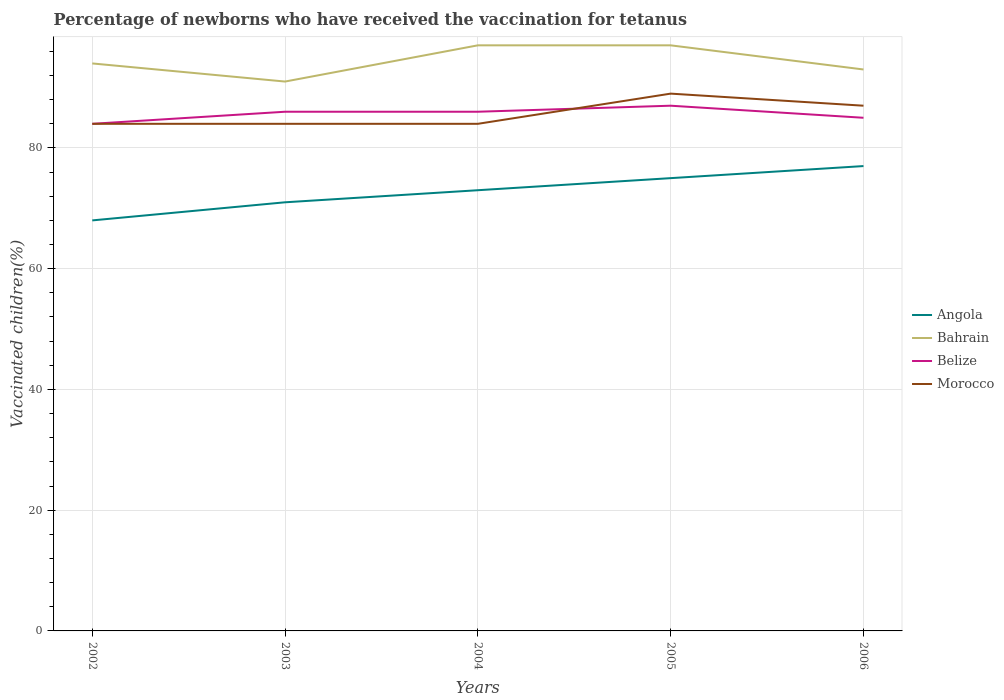How many different coloured lines are there?
Ensure brevity in your answer.  4. Does the line corresponding to Angola intersect with the line corresponding to Belize?
Ensure brevity in your answer.  No. In which year was the percentage of vaccinated children in Belize maximum?
Your answer should be very brief. 2002. What is the difference between the highest and the lowest percentage of vaccinated children in Belize?
Keep it short and to the point. 3. Is the percentage of vaccinated children in Belize strictly greater than the percentage of vaccinated children in Angola over the years?
Give a very brief answer. No. Are the values on the major ticks of Y-axis written in scientific E-notation?
Make the answer very short. No. Does the graph contain any zero values?
Offer a terse response. No. Where does the legend appear in the graph?
Keep it short and to the point. Center right. How many legend labels are there?
Offer a very short reply. 4. How are the legend labels stacked?
Your response must be concise. Vertical. What is the title of the graph?
Make the answer very short. Percentage of newborns who have received the vaccination for tetanus. What is the label or title of the X-axis?
Give a very brief answer. Years. What is the label or title of the Y-axis?
Provide a succinct answer. Vaccinated children(%). What is the Vaccinated children(%) in Bahrain in 2002?
Provide a succinct answer. 94. What is the Vaccinated children(%) in Belize in 2002?
Your answer should be compact. 84. What is the Vaccinated children(%) of Morocco in 2002?
Make the answer very short. 84. What is the Vaccinated children(%) in Bahrain in 2003?
Provide a short and direct response. 91. What is the Vaccinated children(%) of Belize in 2003?
Provide a short and direct response. 86. What is the Vaccinated children(%) of Bahrain in 2004?
Offer a terse response. 97. What is the Vaccinated children(%) of Morocco in 2004?
Provide a succinct answer. 84. What is the Vaccinated children(%) of Bahrain in 2005?
Offer a very short reply. 97. What is the Vaccinated children(%) of Morocco in 2005?
Offer a terse response. 89. What is the Vaccinated children(%) in Bahrain in 2006?
Your response must be concise. 93. What is the Vaccinated children(%) in Belize in 2006?
Give a very brief answer. 85. What is the Vaccinated children(%) in Morocco in 2006?
Your answer should be very brief. 87. Across all years, what is the maximum Vaccinated children(%) of Bahrain?
Give a very brief answer. 97. Across all years, what is the maximum Vaccinated children(%) of Belize?
Offer a terse response. 87. Across all years, what is the maximum Vaccinated children(%) in Morocco?
Your response must be concise. 89. Across all years, what is the minimum Vaccinated children(%) in Bahrain?
Ensure brevity in your answer.  91. What is the total Vaccinated children(%) of Angola in the graph?
Provide a succinct answer. 364. What is the total Vaccinated children(%) of Bahrain in the graph?
Ensure brevity in your answer.  472. What is the total Vaccinated children(%) of Belize in the graph?
Your response must be concise. 428. What is the total Vaccinated children(%) of Morocco in the graph?
Your response must be concise. 428. What is the difference between the Vaccinated children(%) of Angola in 2002 and that in 2003?
Your answer should be compact. -3. What is the difference between the Vaccinated children(%) in Angola in 2002 and that in 2004?
Your answer should be very brief. -5. What is the difference between the Vaccinated children(%) in Angola in 2002 and that in 2006?
Your answer should be compact. -9. What is the difference between the Vaccinated children(%) in Morocco in 2002 and that in 2006?
Your response must be concise. -3. What is the difference between the Vaccinated children(%) in Morocco in 2003 and that in 2004?
Ensure brevity in your answer.  0. What is the difference between the Vaccinated children(%) of Angola in 2003 and that in 2005?
Make the answer very short. -4. What is the difference between the Vaccinated children(%) in Belize in 2003 and that in 2005?
Give a very brief answer. -1. What is the difference between the Vaccinated children(%) of Morocco in 2003 and that in 2005?
Give a very brief answer. -5. What is the difference between the Vaccinated children(%) in Bahrain in 2003 and that in 2006?
Your answer should be very brief. -2. What is the difference between the Vaccinated children(%) of Belize in 2003 and that in 2006?
Provide a succinct answer. 1. What is the difference between the Vaccinated children(%) in Morocco in 2003 and that in 2006?
Provide a succinct answer. -3. What is the difference between the Vaccinated children(%) in Angola in 2004 and that in 2006?
Ensure brevity in your answer.  -4. What is the difference between the Vaccinated children(%) of Bahrain in 2004 and that in 2006?
Make the answer very short. 4. What is the difference between the Vaccinated children(%) in Belize in 2004 and that in 2006?
Offer a terse response. 1. What is the difference between the Vaccinated children(%) in Morocco in 2004 and that in 2006?
Offer a very short reply. -3. What is the difference between the Vaccinated children(%) in Bahrain in 2005 and that in 2006?
Ensure brevity in your answer.  4. What is the difference between the Vaccinated children(%) in Belize in 2002 and the Vaccinated children(%) in Morocco in 2003?
Offer a very short reply. 0. What is the difference between the Vaccinated children(%) in Angola in 2002 and the Vaccinated children(%) in Belize in 2004?
Offer a terse response. -18. What is the difference between the Vaccinated children(%) of Angola in 2002 and the Vaccinated children(%) of Bahrain in 2005?
Offer a terse response. -29. What is the difference between the Vaccinated children(%) of Angola in 2002 and the Vaccinated children(%) of Belize in 2005?
Give a very brief answer. -19. What is the difference between the Vaccinated children(%) in Bahrain in 2002 and the Vaccinated children(%) in Belize in 2005?
Offer a very short reply. 7. What is the difference between the Vaccinated children(%) in Belize in 2002 and the Vaccinated children(%) in Morocco in 2005?
Offer a very short reply. -5. What is the difference between the Vaccinated children(%) of Angola in 2002 and the Vaccinated children(%) of Morocco in 2006?
Ensure brevity in your answer.  -19. What is the difference between the Vaccinated children(%) in Bahrain in 2002 and the Vaccinated children(%) in Belize in 2006?
Give a very brief answer. 9. What is the difference between the Vaccinated children(%) of Bahrain in 2002 and the Vaccinated children(%) of Morocco in 2006?
Your response must be concise. 7. What is the difference between the Vaccinated children(%) in Belize in 2002 and the Vaccinated children(%) in Morocco in 2006?
Make the answer very short. -3. What is the difference between the Vaccinated children(%) in Angola in 2003 and the Vaccinated children(%) in Bahrain in 2004?
Make the answer very short. -26. What is the difference between the Vaccinated children(%) of Angola in 2003 and the Vaccinated children(%) of Belize in 2004?
Make the answer very short. -15. What is the difference between the Vaccinated children(%) of Bahrain in 2003 and the Vaccinated children(%) of Belize in 2004?
Provide a short and direct response. 5. What is the difference between the Vaccinated children(%) of Belize in 2003 and the Vaccinated children(%) of Morocco in 2004?
Ensure brevity in your answer.  2. What is the difference between the Vaccinated children(%) in Angola in 2003 and the Vaccinated children(%) in Bahrain in 2005?
Offer a very short reply. -26. What is the difference between the Vaccinated children(%) in Angola in 2003 and the Vaccinated children(%) in Belize in 2005?
Your answer should be very brief. -16. What is the difference between the Vaccinated children(%) in Angola in 2003 and the Vaccinated children(%) in Morocco in 2005?
Your answer should be compact. -18. What is the difference between the Vaccinated children(%) in Bahrain in 2003 and the Vaccinated children(%) in Belize in 2005?
Your answer should be compact. 4. What is the difference between the Vaccinated children(%) in Bahrain in 2003 and the Vaccinated children(%) in Morocco in 2005?
Offer a very short reply. 2. What is the difference between the Vaccinated children(%) of Belize in 2003 and the Vaccinated children(%) of Morocco in 2005?
Make the answer very short. -3. What is the difference between the Vaccinated children(%) of Angola in 2003 and the Vaccinated children(%) of Belize in 2006?
Offer a terse response. -14. What is the difference between the Vaccinated children(%) of Angola in 2003 and the Vaccinated children(%) of Morocco in 2006?
Your response must be concise. -16. What is the difference between the Vaccinated children(%) in Bahrain in 2003 and the Vaccinated children(%) in Morocco in 2006?
Make the answer very short. 4. What is the difference between the Vaccinated children(%) in Angola in 2004 and the Vaccinated children(%) in Belize in 2005?
Ensure brevity in your answer.  -14. What is the difference between the Vaccinated children(%) in Angola in 2004 and the Vaccinated children(%) in Morocco in 2005?
Keep it short and to the point. -16. What is the difference between the Vaccinated children(%) of Bahrain in 2004 and the Vaccinated children(%) of Morocco in 2005?
Your answer should be very brief. 8. What is the difference between the Vaccinated children(%) in Belize in 2004 and the Vaccinated children(%) in Morocco in 2005?
Ensure brevity in your answer.  -3. What is the difference between the Vaccinated children(%) in Angola in 2004 and the Vaccinated children(%) in Bahrain in 2006?
Your answer should be very brief. -20. What is the difference between the Vaccinated children(%) in Angola in 2004 and the Vaccinated children(%) in Belize in 2006?
Ensure brevity in your answer.  -12. What is the difference between the Vaccinated children(%) in Angola in 2004 and the Vaccinated children(%) in Morocco in 2006?
Provide a succinct answer. -14. What is the difference between the Vaccinated children(%) of Belize in 2004 and the Vaccinated children(%) of Morocco in 2006?
Your answer should be compact. -1. What is the difference between the Vaccinated children(%) in Angola in 2005 and the Vaccinated children(%) in Belize in 2006?
Offer a very short reply. -10. What is the difference between the Vaccinated children(%) of Bahrain in 2005 and the Vaccinated children(%) of Belize in 2006?
Your answer should be compact. 12. What is the difference between the Vaccinated children(%) of Bahrain in 2005 and the Vaccinated children(%) of Morocco in 2006?
Ensure brevity in your answer.  10. What is the difference between the Vaccinated children(%) in Belize in 2005 and the Vaccinated children(%) in Morocco in 2006?
Offer a terse response. 0. What is the average Vaccinated children(%) of Angola per year?
Give a very brief answer. 72.8. What is the average Vaccinated children(%) in Bahrain per year?
Provide a short and direct response. 94.4. What is the average Vaccinated children(%) of Belize per year?
Keep it short and to the point. 85.6. What is the average Vaccinated children(%) of Morocco per year?
Your answer should be very brief. 85.6. In the year 2002, what is the difference between the Vaccinated children(%) of Angola and Vaccinated children(%) of Bahrain?
Offer a very short reply. -26. In the year 2002, what is the difference between the Vaccinated children(%) in Angola and Vaccinated children(%) in Belize?
Provide a short and direct response. -16. In the year 2002, what is the difference between the Vaccinated children(%) of Angola and Vaccinated children(%) of Morocco?
Ensure brevity in your answer.  -16. In the year 2002, what is the difference between the Vaccinated children(%) in Belize and Vaccinated children(%) in Morocco?
Offer a very short reply. 0. In the year 2003, what is the difference between the Vaccinated children(%) of Angola and Vaccinated children(%) of Bahrain?
Your answer should be compact. -20. In the year 2003, what is the difference between the Vaccinated children(%) of Angola and Vaccinated children(%) of Belize?
Your answer should be very brief. -15. In the year 2003, what is the difference between the Vaccinated children(%) of Angola and Vaccinated children(%) of Morocco?
Offer a very short reply. -13. In the year 2003, what is the difference between the Vaccinated children(%) in Bahrain and Vaccinated children(%) in Morocco?
Offer a very short reply. 7. In the year 2003, what is the difference between the Vaccinated children(%) of Belize and Vaccinated children(%) of Morocco?
Offer a terse response. 2. In the year 2004, what is the difference between the Vaccinated children(%) of Angola and Vaccinated children(%) of Bahrain?
Your response must be concise. -24. In the year 2004, what is the difference between the Vaccinated children(%) in Angola and Vaccinated children(%) in Belize?
Give a very brief answer. -13. In the year 2004, what is the difference between the Vaccinated children(%) of Bahrain and Vaccinated children(%) of Belize?
Offer a very short reply. 11. In the year 2004, what is the difference between the Vaccinated children(%) of Bahrain and Vaccinated children(%) of Morocco?
Your answer should be very brief. 13. In the year 2004, what is the difference between the Vaccinated children(%) in Belize and Vaccinated children(%) in Morocco?
Offer a terse response. 2. In the year 2005, what is the difference between the Vaccinated children(%) in Angola and Vaccinated children(%) in Bahrain?
Provide a succinct answer. -22. In the year 2005, what is the difference between the Vaccinated children(%) in Angola and Vaccinated children(%) in Morocco?
Provide a short and direct response. -14. In the year 2006, what is the difference between the Vaccinated children(%) in Bahrain and Vaccinated children(%) in Morocco?
Ensure brevity in your answer.  6. In the year 2006, what is the difference between the Vaccinated children(%) in Belize and Vaccinated children(%) in Morocco?
Give a very brief answer. -2. What is the ratio of the Vaccinated children(%) of Angola in 2002 to that in 2003?
Your answer should be very brief. 0.96. What is the ratio of the Vaccinated children(%) in Bahrain in 2002 to that in 2003?
Make the answer very short. 1.03. What is the ratio of the Vaccinated children(%) of Belize in 2002 to that in 2003?
Ensure brevity in your answer.  0.98. What is the ratio of the Vaccinated children(%) of Angola in 2002 to that in 2004?
Make the answer very short. 0.93. What is the ratio of the Vaccinated children(%) in Bahrain in 2002 to that in 2004?
Keep it short and to the point. 0.97. What is the ratio of the Vaccinated children(%) in Belize in 2002 to that in 2004?
Offer a very short reply. 0.98. What is the ratio of the Vaccinated children(%) of Morocco in 2002 to that in 2004?
Your answer should be very brief. 1. What is the ratio of the Vaccinated children(%) in Angola in 2002 to that in 2005?
Give a very brief answer. 0.91. What is the ratio of the Vaccinated children(%) in Bahrain in 2002 to that in 2005?
Your answer should be very brief. 0.97. What is the ratio of the Vaccinated children(%) in Belize in 2002 to that in 2005?
Make the answer very short. 0.97. What is the ratio of the Vaccinated children(%) of Morocco in 2002 to that in 2005?
Your answer should be very brief. 0.94. What is the ratio of the Vaccinated children(%) in Angola in 2002 to that in 2006?
Ensure brevity in your answer.  0.88. What is the ratio of the Vaccinated children(%) of Bahrain in 2002 to that in 2006?
Your answer should be compact. 1.01. What is the ratio of the Vaccinated children(%) in Belize in 2002 to that in 2006?
Offer a very short reply. 0.99. What is the ratio of the Vaccinated children(%) of Morocco in 2002 to that in 2006?
Give a very brief answer. 0.97. What is the ratio of the Vaccinated children(%) in Angola in 2003 to that in 2004?
Give a very brief answer. 0.97. What is the ratio of the Vaccinated children(%) in Bahrain in 2003 to that in 2004?
Provide a short and direct response. 0.94. What is the ratio of the Vaccinated children(%) of Angola in 2003 to that in 2005?
Your response must be concise. 0.95. What is the ratio of the Vaccinated children(%) of Bahrain in 2003 to that in 2005?
Provide a short and direct response. 0.94. What is the ratio of the Vaccinated children(%) in Morocco in 2003 to that in 2005?
Your answer should be compact. 0.94. What is the ratio of the Vaccinated children(%) of Angola in 2003 to that in 2006?
Offer a very short reply. 0.92. What is the ratio of the Vaccinated children(%) in Bahrain in 2003 to that in 2006?
Provide a short and direct response. 0.98. What is the ratio of the Vaccinated children(%) in Belize in 2003 to that in 2006?
Provide a short and direct response. 1.01. What is the ratio of the Vaccinated children(%) in Morocco in 2003 to that in 2006?
Make the answer very short. 0.97. What is the ratio of the Vaccinated children(%) of Angola in 2004 to that in 2005?
Provide a succinct answer. 0.97. What is the ratio of the Vaccinated children(%) of Bahrain in 2004 to that in 2005?
Make the answer very short. 1. What is the ratio of the Vaccinated children(%) in Belize in 2004 to that in 2005?
Make the answer very short. 0.99. What is the ratio of the Vaccinated children(%) in Morocco in 2004 to that in 2005?
Offer a very short reply. 0.94. What is the ratio of the Vaccinated children(%) in Angola in 2004 to that in 2006?
Your response must be concise. 0.95. What is the ratio of the Vaccinated children(%) of Bahrain in 2004 to that in 2006?
Your response must be concise. 1.04. What is the ratio of the Vaccinated children(%) in Belize in 2004 to that in 2006?
Offer a terse response. 1.01. What is the ratio of the Vaccinated children(%) in Morocco in 2004 to that in 2006?
Provide a succinct answer. 0.97. What is the ratio of the Vaccinated children(%) of Bahrain in 2005 to that in 2006?
Provide a succinct answer. 1.04. What is the ratio of the Vaccinated children(%) in Belize in 2005 to that in 2006?
Provide a short and direct response. 1.02. What is the difference between the highest and the second highest Vaccinated children(%) in Bahrain?
Your response must be concise. 0. What is the difference between the highest and the second highest Vaccinated children(%) in Belize?
Offer a terse response. 1. What is the difference between the highest and the lowest Vaccinated children(%) in Angola?
Your answer should be compact. 9. What is the difference between the highest and the lowest Vaccinated children(%) of Morocco?
Offer a terse response. 5. 